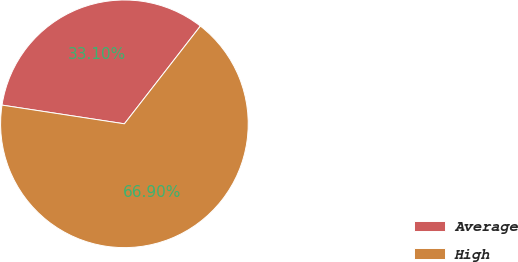Convert chart. <chart><loc_0><loc_0><loc_500><loc_500><pie_chart><fcel>Average<fcel>High<nl><fcel>33.1%<fcel>66.9%<nl></chart> 